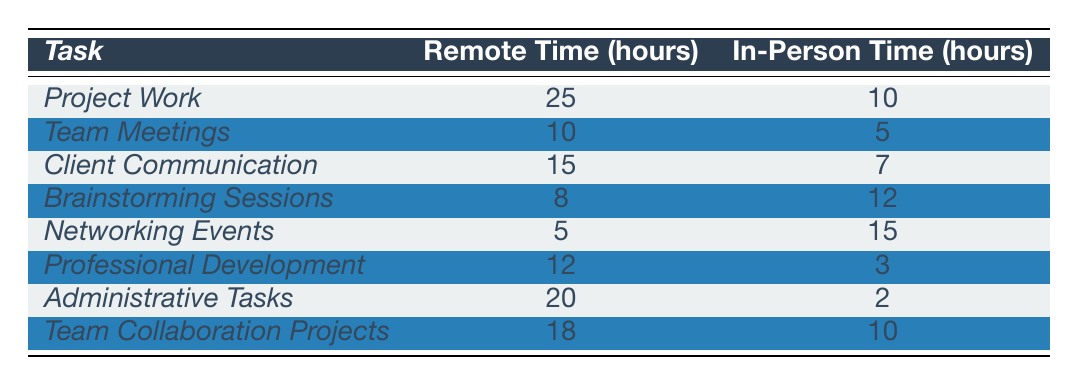What is the total remote time spent on Project Work and Team Meetings? The remote time for Project Work is 25 hours and for Team Meetings is 10 hours. Adding these together gives 25 + 10 = 35 hours.
Answer: 35 hours Which task has the highest in-person time? Looking through the table, Networking Events has the highest in-person time at 15 hours, compared to others.
Answer: Networking Events What is the difference between remote time and in-person time for Client Communication? The remote time for Client Communication is 15 hours and in-person time is 7 hours. The difference is 15 - 7 = 8 hours.
Answer: 8 hours Is the remote time for Administrative Tasks greater than that for Team Collaboration Projects? The remote time for Administrative Tasks is 20 hours and for Team Collaboration Projects is 18 hours. Since 20 is greater than 18, the answer is yes.
Answer: Yes What percentage of time spent on Professional Development is remote? The remote time for Professional Development is 12 hours and the in-person time is 3 hours. The total time spent is 12 + 3 = 15 hours. The percentage is (12 / 15) × 100 = 80%.
Answer: 80% Which two tasks combined have a total remote time of less than 30 hours? The tasks with remote times of 25 hours (Project Work) and 5 hours (Networking Events) add up to 30 hours, which meets the criteria. As a check, the other combinations exceed 30 hours.
Answer: Project Work and Networking Events If you only consider tasks with more remote time than in-person time, how many tasks meet this criterion? Looking through the table, the tasks that fulfill this condition are Project Work, Team Meetings, Client Communication, Professional Development, and Team Collaboration Projects. This makes a total of 5 tasks.
Answer: 5 tasks What is the average remote time across all tasks? Adding all remote times: 25 + 10 + 15 + 8 + 5 + 12 + 20 + 18 = 113 hours. There are 8 tasks, so the average is 113 / 8 = 14.125 hours, which rounds to 14.13 hours.
Answer: 14.13 hours Which task has the least remote time spent? The task with the least remote time is Networking Events, with only 5 hours compared to others.
Answer: Networking Events What is the total in-person time across all tasks? Adding the in-person times gives: 10 + 5 + 7 + 12 + 15 + 3 + 2 + 10 = 64 hours.
Answer: 64 hours 